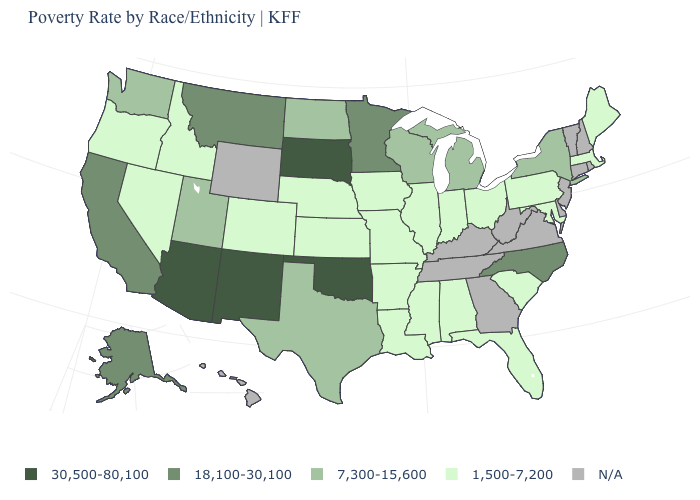What is the value of Alaska?
Be succinct. 18,100-30,100. What is the value of Utah?
Answer briefly. 7,300-15,600. What is the value of Washington?
Answer briefly. 7,300-15,600. Is the legend a continuous bar?
Be succinct. No. What is the value of Iowa?
Answer briefly. 1,500-7,200. What is the highest value in the USA?
Concise answer only. 30,500-80,100. Name the states that have a value in the range 18,100-30,100?
Write a very short answer. Alaska, California, Minnesota, Montana, North Carolina. What is the value of Alabama?
Concise answer only. 1,500-7,200. Does Oklahoma have the lowest value in the USA?
Short answer required. No. Which states have the highest value in the USA?
Quick response, please. Arizona, New Mexico, Oklahoma, South Dakota. Name the states that have a value in the range 30,500-80,100?
Quick response, please. Arizona, New Mexico, Oklahoma, South Dakota. Name the states that have a value in the range N/A?
Concise answer only. Connecticut, Delaware, Georgia, Hawaii, Kentucky, New Hampshire, New Jersey, Rhode Island, Tennessee, Vermont, Virginia, West Virginia, Wyoming. What is the lowest value in the MidWest?
Write a very short answer. 1,500-7,200. 